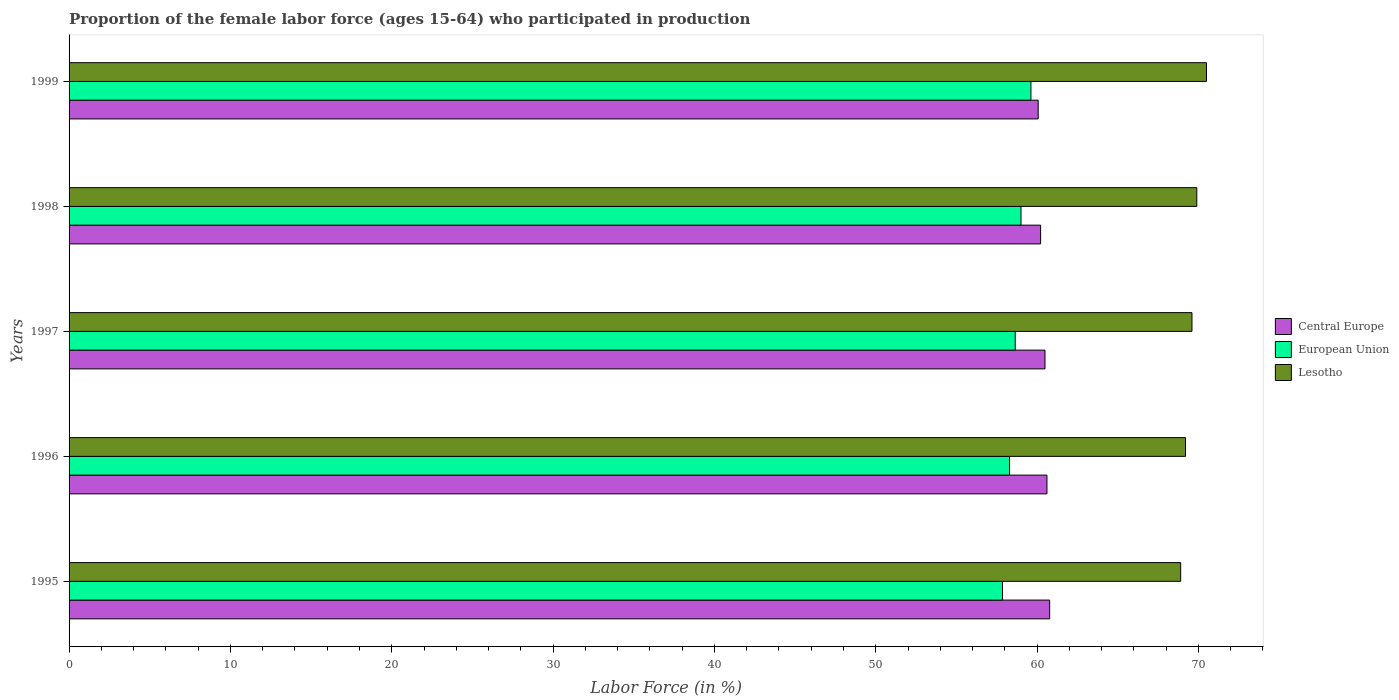How many groups of bars are there?
Ensure brevity in your answer.  5. Are the number of bars on each tick of the Y-axis equal?
Give a very brief answer. Yes. How many bars are there on the 2nd tick from the top?
Ensure brevity in your answer.  3. How many bars are there on the 1st tick from the bottom?
Your answer should be very brief. 3. What is the label of the 1st group of bars from the top?
Give a very brief answer. 1999. In how many cases, is the number of bars for a given year not equal to the number of legend labels?
Your answer should be very brief. 0. What is the proportion of the female labor force who participated in production in European Union in 1998?
Offer a very short reply. 59. Across all years, what is the maximum proportion of the female labor force who participated in production in Central Europe?
Provide a short and direct response. 60.78. Across all years, what is the minimum proportion of the female labor force who participated in production in European Union?
Offer a terse response. 57.86. In which year was the proportion of the female labor force who participated in production in Lesotho maximum?
Your response must be concise. 1999. What is the total proportion of the female labor force who participated in production in Lesotho in the graph?
Your response must be concise. 348.1. What is the difference between the proportion of the female labor force who participated in production in European Union in 1995 and that in 1997?
Keep it short and to the point. -0.79. What is the difference between the proportion of the female labor force who participated in production in Lesotho in 1997 and the proportion of the female labor force who participated in production in Central Europe in 1998?
Offer a terse response. 9.38. What is the average proportion of the female labor force who participated in production in Lesotho per year?
Your response must be concise. 69.62. In the year 1996, what is the difference between the proportion of the female labor force who participated in production in Central Europe and proportion of the female labor force who participated in production in European Union?
Ensure brevity in your answer.  2.32. In how many years, is the proportion of the female labor force who participated in production in European Union greater than 66 %?
Provide a short and direct response. 0. What is the ratio of the proportion of the female labor force who participated in production in European Union in 1997 to that in 1998?
Offer a terse response. 0.99. What is the difference between the highest and the second highest proportion of the female labor force who participated in production in Central Europe?
Ensure brevity in your answer.  0.17. What is the difference between the highest and the lowest proportion of the female labor force who participated in production in Central Europe?
Give a very brief answer. 0.71. What does the 1st bar from the top in 1998 represents?
Provide a short and direct response. Lesotho. What does the 2nd bar from the bottom in 1997 represents?
Provide a short and direct response. European Union. Is it the case that in every year, the sum of the proportion of the female labor force who participated in production in Lesotho and proportion of the female labor force who participated in production in Central Europe is greater than the proportion of the female labor force who participated in production in European Union?
Offer a terse response. Yes. How many bars are there?
Keep it short and to the point. 15. What is the difference between two consecutive major ticks on the X-axis?
Your answer should be compact. 10. Are the values on the major ticks of X-axis written in scientific E-notation?
Offer a terse response. No. Does the graph contain any zero values?
Keep it short and to the point. No. How many legend labels are there?
Give a very brief answer. 3. What is the title of the graph?
Keep it short and to the point. Proportion of the female labor force (ages 15-64) who participated in production. Does "European Union" appear as one of the legend labels in the graph?
Make the answer very short. Yes. What is the label or title of the X-axis?
Give a very brief answer. Labor Force (in %). What is the Labor Force (in %) of Central Europe in 1995?
Provide a short and direct response. 60.78. What is the Labor Force (in %) of European Union in 1995?
Offer a very short reply. 57.86. What is the Labor Force (in %) in Lesotho in 1995?
Your response must be concise. 68.9. What is the Labor Force (in %) of Central Europe in 1996?
Provide a short and direct response. 60.61. What is the Labor Force (in %) in European Union in 1996?
Ensure brevity in your answer.  58.29. What is the Labor Force (in %) of Lesotho in 1996?
Provide a succinct answer. 69.2. What is the Labor Force (in %) of Central Europe in 1997?
Keep it short and to the point. 60.49. What is the Labor Force (in %) of European Union in 1997?
Your answer should be compact. 58.65. What is the Labor Force (in %) in Lesotho in 1997?
Keep it short and to the point. 69.6. What is the Labor Force (in %) of Central Europe in 1998?
Keep it short and to the point. 60.22. What is the Labor Force (in %) of European Union in 1998?
Keep it short and to the point. 59. What is the Labor Force (in %) of Lesotho in 1998?
Offer a terse response. 69.9. What is the Labor Force (in %) of Central Europe in 1999?
Keep it short and to the point. 60.07. What is the Labor Force (in %) in European Union in 1999?
Give a very brief answer. 59.62. What is the Labor Force (in %) in Lesotho in 1999?
Your answer should be very brief. 70.5. Across all years, what is the maximum Labor Force (in %) of Central Europe?
Provide a short and direct response. 60.78. Across all years, what is the maximum Labor Force (in %) in European Union?
Offer a terse response. 59.62. Across all years, what is the maximum Labor Force (in %) in Lesotho?
Ensure brevity in your answer.  70.5. Across all years, what is the minimum Labor Force (in %) of Central Europe?
Offer a terse response. 60.07. Across all years, what is the minimum Labor Force (in %) in European Union?
Provide a succinct answer. 57.86. Across all years, what is the minimum Labor Force (in %) in Lesotho?
Your response must be concise. 68.9. What is the total Labor Force (in %) of Central Europe in the graph?
Offer a terse response. 302.17. What is the total Labor Force (in %) of European Union in the graph?
Keep it short and to the point. 293.42. What is the total Labor Force (in %) in Lesotho in the graph?
Offer a very short reply. 348.1. What is the difference between the Labor Force (in %) of Central Europe in 1995 and that in 1996?
Ensure brevity in your answer.  0.17. What is the difference between the Labor Force (in %) in European Union in 1995 and that in 1996?
Give a very brief answer. -0.44. What is the difference between the Labor Force (in %) of Central Europe in 1995 and that in 1997?
Offer a terse response. 0.29. What is the difference between the Labor Force (in %) of European Union in 1995 and that in 1997?
Your answer should be very brief. -0.79. What is the difference between the Labor Force (in %) of Lesotho in 1995 and that in 1997?
Provide a succinct answer. -0.7. What is the difference between the Labor Force (in %) in Central Europe in 1995 and that in 1998?
Keep it short and to the point. 0.56. What is the difference between the Labor Force (in %) in European Union in 1995 and that in 1998?
Ensure brevity in your answer.  -1.15. What is the difference between the Labor Force (in %) of Central Europe in 1995 and that in 1999?
Give a very brief answer. 0.71. What is the difference between the Labor Force (in %) in European Union in 1995 and that in 1999?
Your answer should be compact. -1.76. What is the difference between the Labor Force (in %) in Lesotho in 1995 and that in 1999?
Offer a very short reply. -1.6. What is the difference between the Labor Force (in %) in Central Europe in 1996 and that in 1997?
Your answer should be very brief. 0.12. What is the difference between the Labor Force (in %) in European Union in 1996 and that in 1997?
Offer a very short reply. -0.35. What is the difference between the Labor Force (in %) of Central Europe in 1996 and that in 1998?
Give a very brief answer. 0.39. What is the difference between the Labor Force (in %) in European Union in 1996 and that in 1998?
Your answer should be compact. -0.71. What is the difference between the Labor Force (in %) in Lesotho in 1996 and that in 1998?
Give a very brief answer. -0.7. What is the difference between the Labor Force (in %) of Central Europe in 1996 and that in 1999?
Provide a short and direct response. 0.54. What is the difference between the Labor Force (in %) in European Union in 1996 and that in 1999?
Provide a succinct answer. -1.33. What is the difference between the Labor Force (in %) of Central Europe in 1997 and that in 1998?
Your answer should be compact. 0.27. What is the difference between the Labor Force (in %) in European Union in 1997 and that in 1998?
Your answer should be compact. -0.36. What is the difference between the Labor Force (in %) in Lesotho in 1997 and that in 1998?
Provide a short and direct response. -0.3. What is the difference between the Labor Force (in %) in Central Europe in 1997 and that in 1999?
Provide a succinct answer. 0.42. What is the difference between the Labor Force (in %) in European Union in 1997 and that in 1999?
Your response must be concise. -0.97. What is the difference between the Labor Force (in %) in Central Europe in 1998 and that in 1999?
Provide a short and direct response. 0.15. What is the difference between the Labor Force (in %) in European Union in 1998 and that in 1999?
Offer a very short reply. -0.62. What is the difference between the Labor Force (in %) of Lesotho in 1998 and that in 1999?
Keep it short and to the point. -0.6. What is the difference between the Labor Force (in %) of Central Europe in 1995 and the Labor Force (in %) of European Union in 1996?
Offer a terse response. 2.49. What is the difference between the Labor Force (in %) in Central Europe in 1995 and the Labor Force (in %) in Lesotho in 1996?
Give a very brief answer. -8.42. What is the difference between the Labor Force (in %) in European Union in 1995 and the Labor Force (in %) in Lesotho in 1996?
Make the answer very short. -11.34. What is the difference between the Labor Force (in %) in Central Europe in 1995 and the Labor Force (in %) in European Union in 1997?
Provide a succinct answer. 2.13. What is the difference between the Labor Force (in %) of Central Europe in 1995 and the Labor Force (in %) of Lesotho in 1997?
Provide a short and direct response. -8.82. What is the difference between the Labor Force (in %) in European Union in 1995 and the Labor Force (in %) in Lesotho in 1997?
Your response must be concise. -11.74. What is the difference between the Labor Force (in %) of Central Europe in 1995 and the Labor Force (in %) of European Union in 1998?
Your answer should be compact. 1.78. What is the difference between the Labor Force (in %) in Central Europe in 1995 and the Labor Force (in %) in Lesotho in 1998?
Provide a succinct answer. -9.12. What is the difference between the Labor Force (in %) of European Union in 1995 and the Labor Force (in %) of Lesotho in 1998?
Ensure brevity in your answer.  -12.04. What is the difference between the Labor Force (in %) of Central Europe in 1995 and the Labor Force (in %) of European Union in 1999?
Provide a short and direct response. 1.16. What is the difference between the Labor Force (in %) of Central Europe in 1995 and the Labor Force (in %) of Lesotho in 1999?
Provide a short and direct response. -9.72. What is the difference between the Labor Force (in %) in European Union in 1995 and the Labor Force (in %) in Lesotho in 1999?
Your response must be concise. -12.64. What is the difference between the Labor Force (in %) of Central Europe in 1996 and the Labor Force (in %) of European Union in 1997?
Your answer should be very brief. 1.97. What is the difference between the Labor Force (in %) of Central Europe in 1996 and the Labor Force (in %) of Lesotho in 1997?
Provide a short and direct response. -8.99. What is the difference between the Labor Force (in %) of European Union in 1996 and the Labor Force (in %) of Lesotho in 1997?
Provide a succinct answer. -11.31. What is the difference between the Labor Force (in %) in Central Europe in 1996 and the Labor Force (in %) in European Union in 1998?
Your answer should be compact. 1.61. What is the difference between the Labor Force (in %) of Central Europe in 1996 and the Labor Force (in %) of Lesotho in 1998?
Make the answer very short. -9.29. What is the difference between the Labor Force (in %) of European Union in 1996 and the Labor Force (in %) of Lesotho in 1998?
Your answer should be compact. -11.61. What is the difference between the Labor Force (in %) of Central Europe in 1996 and the Labor Force (in %) of Lesotho in 1999?
Provide a short and direct response. -9.89. What is the difference between the Labor Force (in %) in European Union in 1996 and the Labor Force (in %) in Lesotho in 1999?
Make the answer very short. -12.21. What is the difference between the Labor Force (in %) in Central Europe in 1997 and the Labor Force (in %) in European Union in 1998?
Provide a short and direct response. 1.49. What is the difference between the Labor Force (in %) in Central Europe in 1997 and the Labor Force (in %) in Lesotho in 1998?
Keep it short and to the point. -9.41. What is the difference between the Labor Force (in %) in European Union in 1997 and the Labor Force (in %) in Lesotho in 1998?
Offer a terse response. -11.25. What is the difference between the Labor Force (in %) in Central Europe in 1997 and the Labor Force (in %) in European Union in 1999?
Offer a terse response. 0.87. What is the difference between the Labor Force (in %) of Central Europe in 1997 and the Labor Force (in %) of Lesotho in 1999?
Your answer should be compact. -10.01. What is the difference between the Labor Force (in %) in European Union in 1997 and the Labor Force (in %) in Lesotho in 1999?
Provide a short and direct response. -11.85. What is the difference between the Labor Force (in %) of Central Europe in 1998 and the Labor Force (in %) of European Union in 1999?
Offer a terse response. 0.6. What is the difference between the Labor Force (in %) in Central Europe in 1998 and the Labor Force (in %) in Lesotho in 1999?
Make the answer very short. -10.28. What is the difference between the Labor Force (in %) of European Union in 1998 and the Labor Force (in %) of Lesotho in 1999?
Your answer should be compact. -11.5. What is the average Labor Force (in %) of Central Europe per year?
Offer a terse response. 60.43. What is the average Labor Force (in %) in European Union per year?
Provide a succinct answer. 58.68. What is the average Labor Force (in %) in Lesotho per year?
Make the answer very short. 69.62. In the year 1995, what is the difference between the Labor Force (in %) in Central Europe and Labor Force (in %) in European Union?
Provide a short and direct response. 2.92. In the year 1995, what is the difference between the Labor Force (in %) in Central Europe and Labor Force (in %) in Lesotho?
Your response must be concise. -8.12. In the year 1995, what is the difference between the Labor Force (in %) in European Union and Labor Force (in %) in Lesotho?
Provide a succinct answer. -11.04. In the year 1996, what is the difference between the Labor Force (in %) in Central Europe and Labor Force (in %) in European Union?
Offer a terse response. 2.32. In the year 1996, what is the difference between the Labor Force (in %) of Central Europe and Labor Force (in %) of Lesotho?
Your response must be concise. -8.59. In the year 1996, what is the difference between the Labor Force (in %) in European Union and Labor Force (in %) in Lesotho?
Offer a very short reply. -10.91. In the year 1997, what is the difference between the Labor Force (in %) of Central Europe and Labor Force (in %) of European Union?
Your answer should be very brief. 1.85. In the year 1997, what is the difference between the Labor Force (in %) of Central Europe and Labor Force (in %) of Lesotho?
Your response must be concise. -9.11. In the year 1997, what is the difference between the Labor Force (in %) of European Union and Labor Force (in %) of Lesotho?
Provide a succinct answer. -10.95. In the year 1998, what is the difference between the Labor Force (in %) of Central Europe and Labor Force (in %) of European Union?
Your response must be concise. 1.22. In the year 1998, what is the difference between the Labor Force (in %) of Central Europe and Labor Force (in %) of Lesotho?
Ensure brevity in your answer.  -9.68. In the year 1998, what is the difference between the Labor Force (in %) in European Union and Labor Force (in %) in Lesotho?
Make the answer very short. -10.9. In the year 1999, what is the difference between the Labor Force (in %) of Central Europe and Labor Force (in %) of European Union?
Your response must be concise. 0.45. In the year 1999, what is the difference between the Labor Force (in %) in Central Europe and Labor Force (in %) in Lesotho?
Keep it short and to the point. -10.43. In the year 1999, what is the difference between the Labor Force (in %) in European Union and Labor Force (in %) in Lesotho?
Keep it short and to the point. -10.88. What is the ratio of the Labor Force (in %) of Central Europe in 1995 to that in 1996?
Your response must be concise. 1. What is the ratio of the Labor Force (in %) of European Union in 1995 to that in 1997?
Ensure brevity in your answer.  0.99. What is the ratio of the Labor Force (in %) of Lesotho in 1995 to that in 1997?
Provide a succinct answer. 0.99. What is the ratio of the Labor Force (in %) of Central Europe in 1995 to that in 1998?
Your answer should be very brief. 1.01. What is the ratio of the Labor Force (in %) of European Union in 1995 to that in 1998?
Ensure brevity in your answer.  0.98. What is the ratio of the Labor Force (in %) in Lesotho in 1995 to that in 1998?
Give a very brief answer. 0.99. What is the ratio of the Labor Force (in %) of Central Europe in 1995 to that in 1999?
Offer a terse response. 1.01. What is the ratio of the Labor Force (in %) of European Union in 1995 to that in 1999?
Provide a succinct answer. 0.97. What is the ratio of the Labor Force (in %) of Lesotho in 1995 to that in 1999?
Offer a terse response. 0.98. What is the ratio of the Labor Force (in %) of Central Europe in 1996 to that in 1997?
Make the answer very short. 1. What is the ratio of the Labor Force (in %) of European Union in 1996 to that in 1997?
Your answer should be very brief. 0.99. What is the ratio of the Labor Force (in %) in Lesotho in 1996 to that in 1997?
Make the answer very short. 0.99. What is the ratio of the Labor Force (in %) of European Union in 1996 to that in 1998?
Ensure brevity in your answer.  0.99. What is the ratio of the Labor Force (in %) in Lesotho in 1996 to that in 1998?
Your response must be concise. 0.99. What is the ratio of the Labor Force (in %) of European Union in 1996 to that in 1999?
Your answer should be compact. 0.98. What is the ratio of the Labor Force (in %) of Lesotho in 1996 to that in 1999?
Provide a short and direct response. 0.98. What is the ratio of the Labor Force (in %) of Central Europe in 1997 to that in 1998?
Offer a terse response. 1. What is the ratio of the Labor Force (in %) in European Union in 1997 to that in 1998?
Offer a terse response. 0.99. What is the ratio of the Labor Force (in %) of European Union in 1997 to that in 1999?
Provide a short and direct response. 0.98. What is the ratio of the Labor Force (in %) of Lesotho in 1997 to that in 1999?
Give a very brief answer. 0.99. What is the ratio of the Labor Force (in %) of Lesotho in 1998 to that in 1999?
Give a very brief answer. 0.99. What is the difference between the highest and the second highest Labor Force (in %) in Central Europe?
Your answer should be compact. 0.17. What is the difference between the highest and the second highest Labor Force (in %) of European Union?
Offer a terse response. 0.62. What is the difference between the highest and the lowest Labor Force (in %) of Central Europe?
Provide a short and direct response. 0.71. What is the difference between the highest and the lowest Labor Force (in %) of European Union?
Keep it short and to the point. 1.76. 